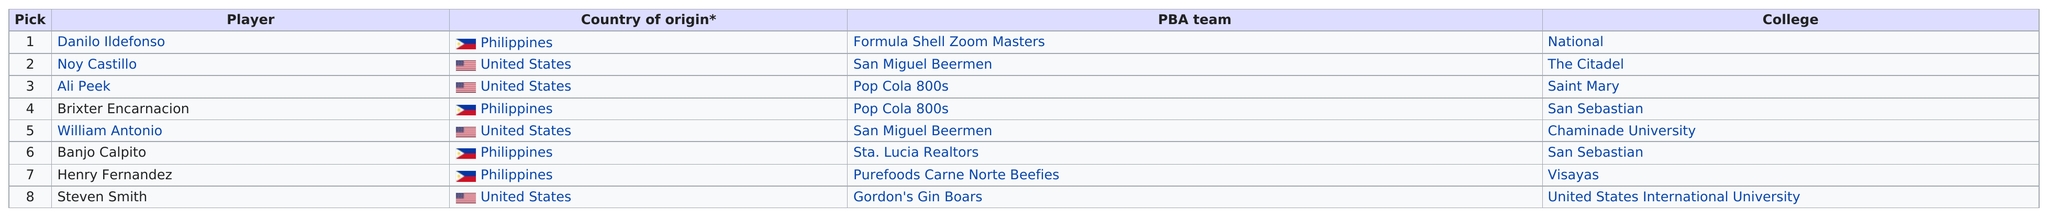Draw attention to some important aspects in this diagram. The player who was selected directly above Calpito is William Antonio. There were fewer than five players selected from the United States. The total amount of participating countries is two. Noy Castillo was the top player selected from the Citadel. Four people from the Philippines are present. 